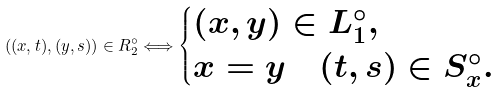<formula> <loc_0><loc_0><loc_500><loc_500>( ( x , t ) , ( y , s ) ) \in R _ { 2 } ^ { \circ } \Longleftrightarrow \begin{cases} ( x , y ) \in L _ { 1 } ^ { \circ } , \\ x = y \quad ( t , s ) \in S _ { x } ^ { \circ } . \end{cases}</formula> 